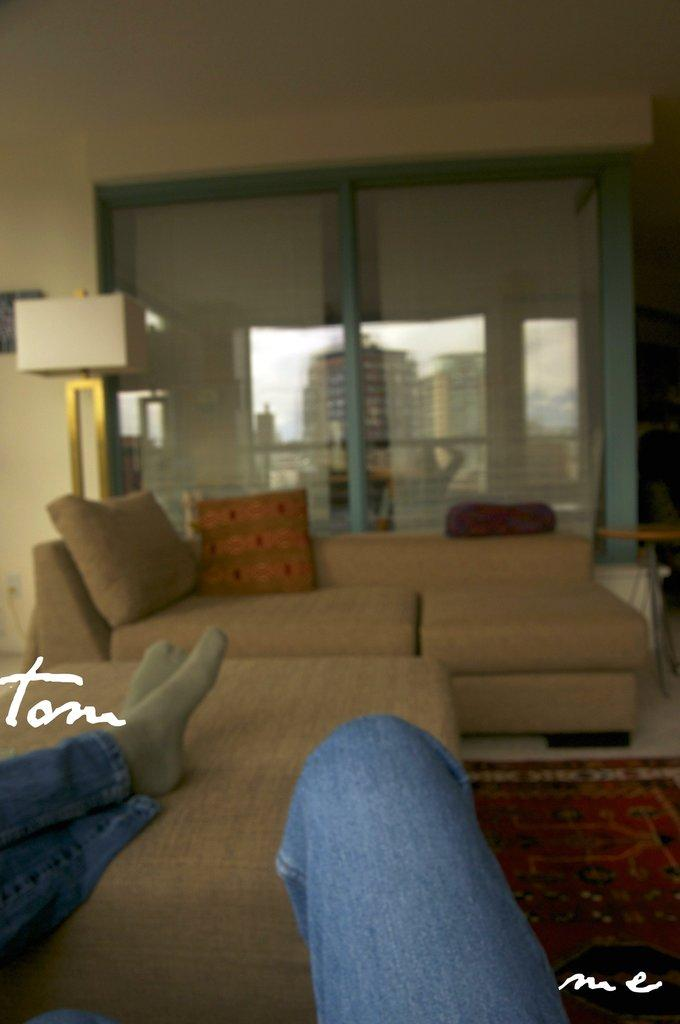What type of space is shown in the image? There is a room in the image. What furniture is present in the room? There is a sofa with pillows in the room. What architectural feature is present in the room? There is a window in the room. What can be seen through the window? Buildings are visible through the window. What is the person in the image doing? There is a person with at least one leg on the bed. Can you see the coast from the window in the image? There is no coast visible through the window in the image; only buildings can be seen. What type of ray is present in the image? There is no ray present in the image. 